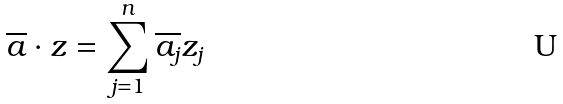<formula> <loc_0><loc_0><loc_500><loc_500>\overline { a } \cdot z = \sum _ { j = 1 } ^ { n } \overline { a _ { j } } z _ { j }</formula> 